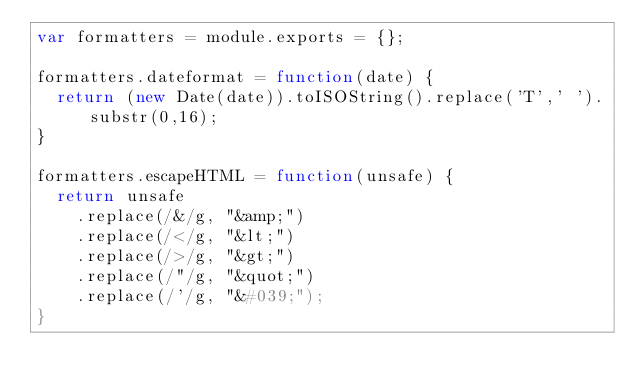<code> <loc_0><loc_0><loc_500><loc_500><_JavaScript_>var formatters = module.exports = {};

formatters.dateformat = function(date) {
	return (new Date(date)).toISOString().replace('T',' ').substr(0,16);
}

formatters.escapeHTML = function(unsafe) {
	return unsafe
		.replace(/&/g, "&amp;")
		.replace(/</g, "&lt;")
		.replace(/>/g, "&gt;")
		.replace(/"/g, "&quot;")
		.replace(/'/g, "&#039;");
}
</code> 